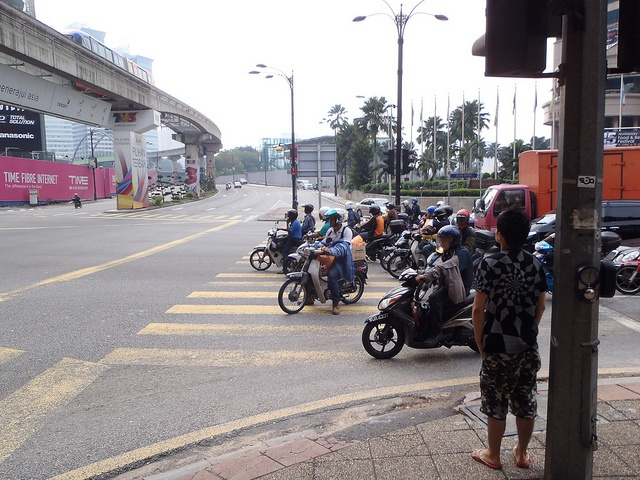Describe the objects in this image and their specific colors. I can see people in gray, black, maroon, and darkgray tones, truck in gray, black, and brown tones, motorcycle in gray, black, darkgray, and lightgray tones, traffic light in gray, black, and white tones, and motorcycle in gray, black, darkgray, and maroon tones in this image. 